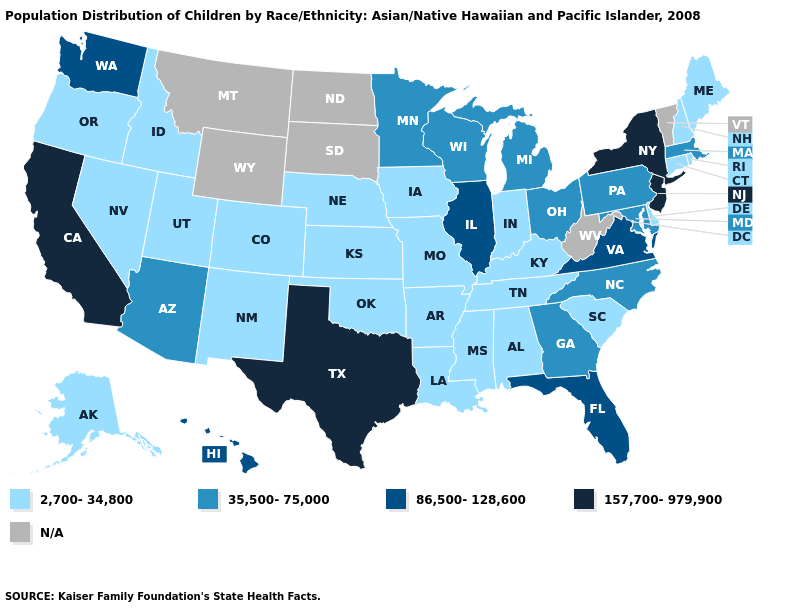What is the value of Arkansas?
Keep it brief. 2,700-34,800. Name the states that have a value in the range 157,700-979,900?
Concise answer only. California, New Jersey, New York, Texas. Does Delaware have the lowest value in the USA?
Quick response, please. Yes. Among the states that border Florida , which have the lowest value?
Short answer required. Alabama. What is the value of Connecticut?
Write a very short answer. 2,700-34,800. What is the lowest value in the USA?
Short answer required. 2,700-34,800. Name the states that have a value in the range 2,700-34,800?
Be succinct. Alabama, Alaska, Arkansas, Colorado, Connecticut, Delaware, Idaho, Indiana, Iowa, Kansas, Kentucky, Louisiana, Maine, Mississippi, Missouri, Nebraska, Nevada, New Hampshire, New Mexico, Oklahoma, Oregon, Rhode Island, South Carolina, Tennessee, Utah. What is the highest value in states that border North Dakota?
Short answer required. 35,500-75,000. Which states have the lowest value in the West?
Write a very short answer. Alaska, Colorado, Idaho, Nevada, New Mexico, Oregon, Utah. Name the states that have a value in the range 86,500-128,600?
Give a very brief answer. Florida, Hawaii, Illinois, Virginia, Washington. What is the value of New Mexico?
Keep it brief. 2,700-34,800. What is the lowest value in the South?
Answer briefly. 2,700-34,800. Does Rhode Island have the highest value in the Northeast?
Give a very brief answer. No. Among the states that border Oklahoma , does Texas have the lowest value?
Concise answer only. No. 